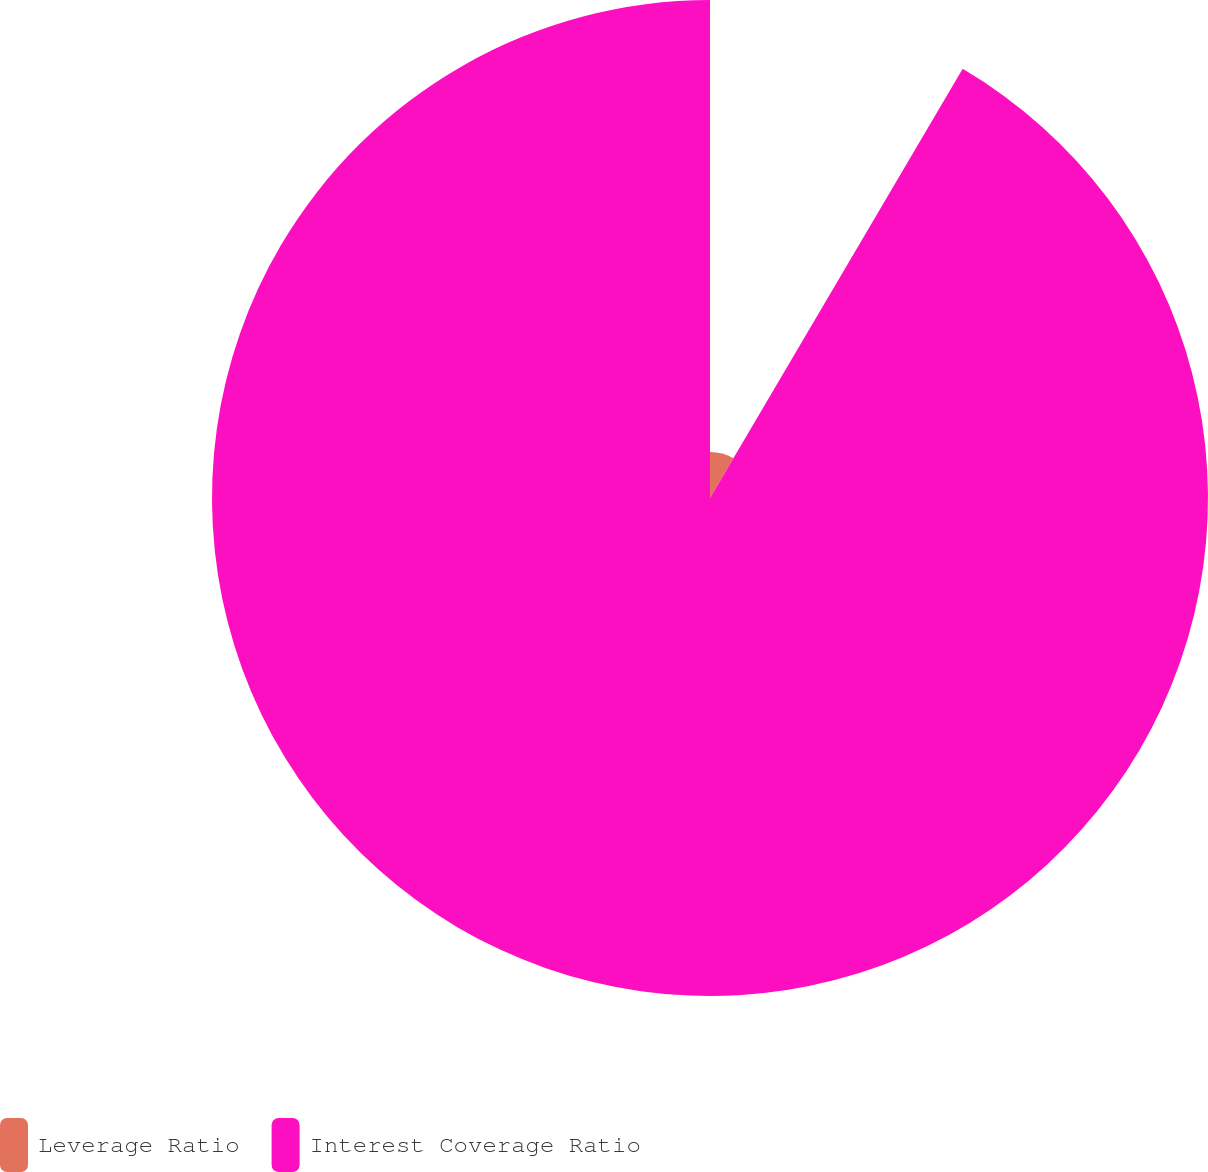Convert chart to OTSL. <chart><loc_0><loc_0><loc_500><loc_500><pie_chart><fcel>Leverage Ratio<fcel>Interest Coverage Ratio<nl><fcel>8.47%<fcel>91.53%<nl></chart> 